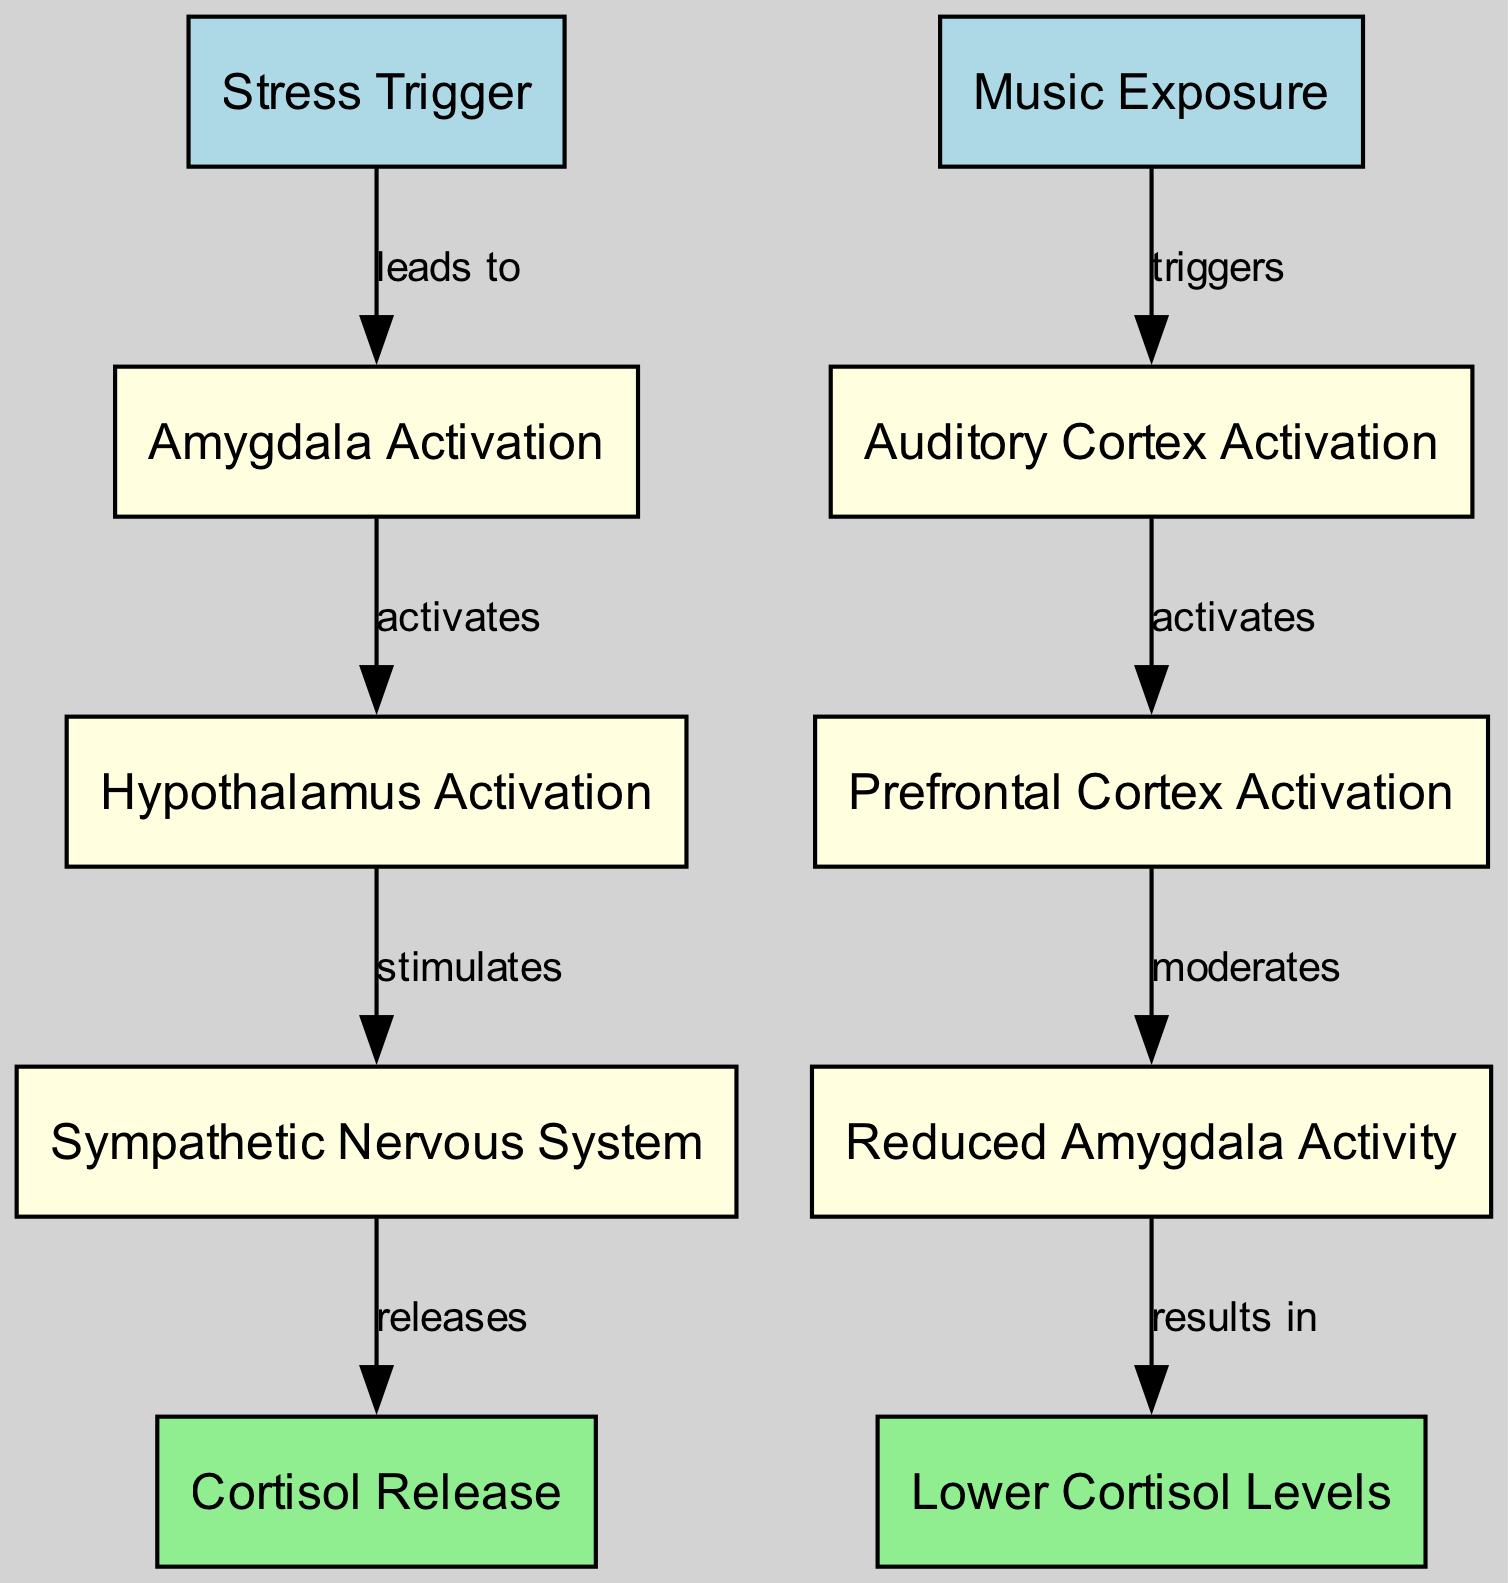What is the starting point of the diagram? The diagram begins with the node labeled "Stress Trigger" which is the first input node. This indicates that stress is the initiating factor leading into the subsequent processing steps.
Answer: Stress Trigger How many total nodes are in the diagram? By counting all the listed nodes in the diagram, we find that there are 10 nodes in total, which includes input, process, and output types.
Answer: 10 What process follows "Amygdala Activation"? The node that follows "Amygdala Activation" in the flow of the diagram is "Hypothalamus Activation". This links the emotional response triggered by stress to further signaling processes in the body.
Answer: Hypothalamus Activation Which node results in "Lower Cortisol Levels"? The process "Reduced Amygdala Activity" leads to "Lower Cortisol Levels," indicating a reduction in the stress hormone as a result of the regulatory processes activated by music.
Answer: Lower Cortisol Levels What triggers the "Auditory Cortex Activation"? The node "Music Exposure" has a direct link to "Auditory Cortex Activation," illustrating that listening to music initiates this neural process.
Answer: Music Exposure What type of node is "Cortisol Release"? "Cortisol Release" is classified as an output node, indicating it represents the final result of the processing actions taken within the pathway after stress activation.
Answer: output Which process moderates activity in the "Prefrontal Cortex"? The link from "Prefrontal Cortex Activation" to "Reduced Amygdala Activity" denotes that the prefrontal cortex plays a role in modulating the activity of the amygdala in response to music.
Answer: moderates How many edges connect the nodes in the pathway? By examining the connections or relationships represented in the edges, we can determine there are 8 distinct edges connecting the nodes in the pathway.
Answer: 8 What is the relationship between "Sympathetic Nervous System" and "Cortisol Release"? The "Sympathetic Nervous System" activates the release of cortisol, establishing a direct process showing how stress influences hormonal responses in the body.
Answer: releases 